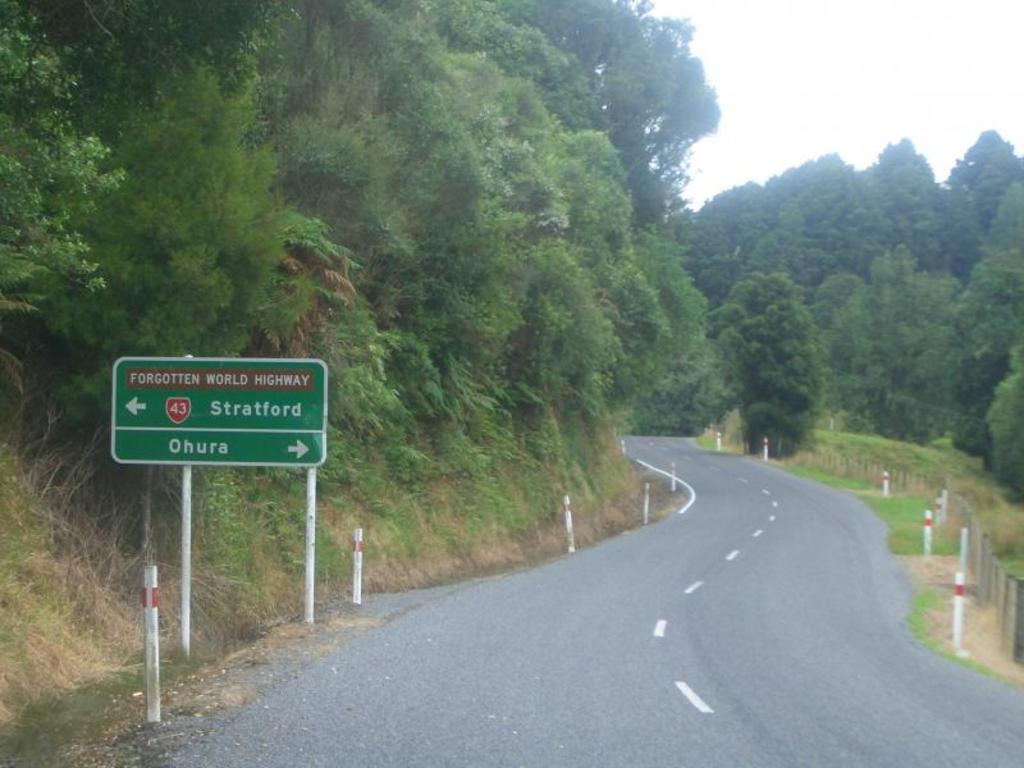<image>
Give a short and clear explanation of the subsequent image. a sign that has the words Ohura on it 